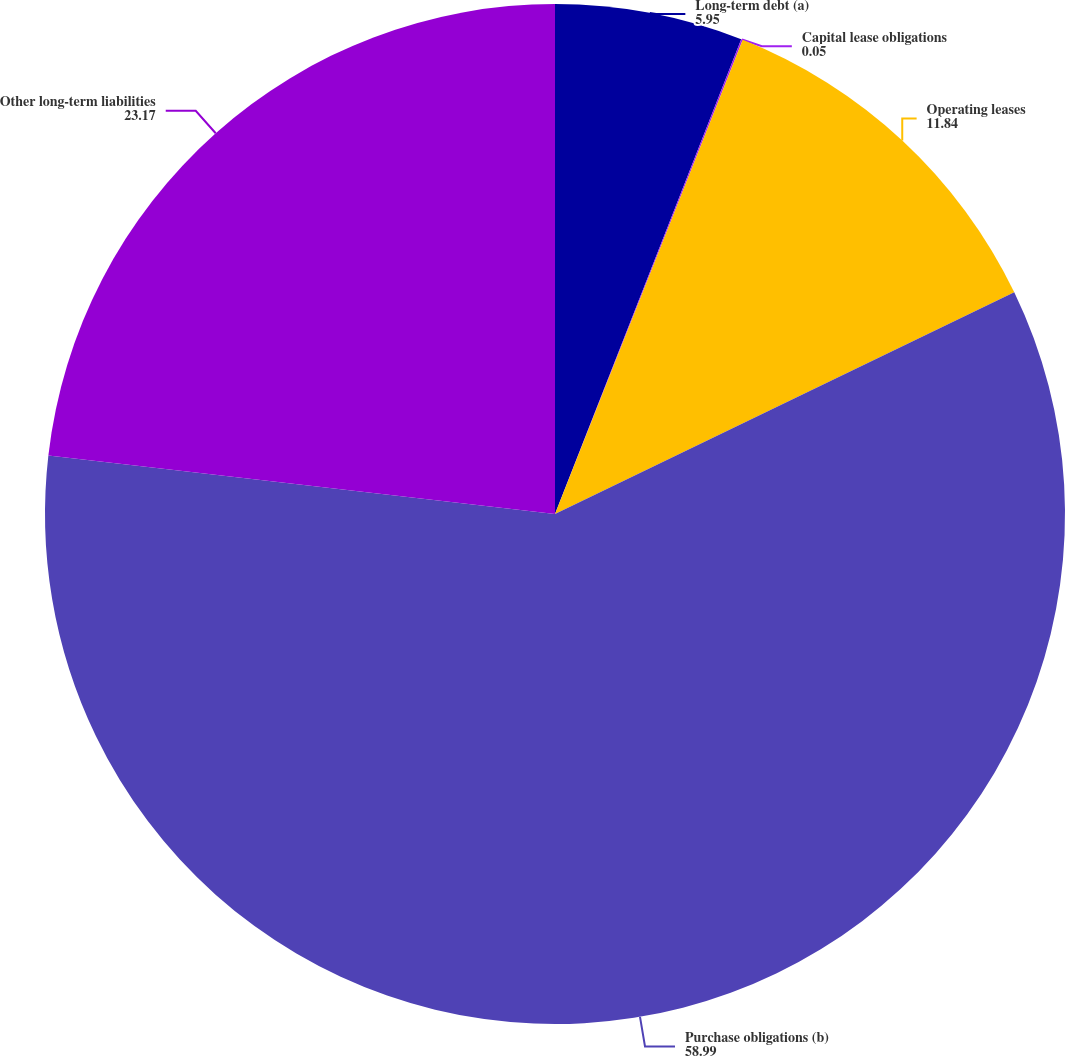<chart> <loc_0><loc_0><loc_500><loc_500><pie_chart><fcel>Long-term debt (a)<fcel>Capital lease obligations<fcel>Operating leases<fcel>Purchase obligations (b)<fcel>Other long-term liabilities<nl><fcel>5.95%<fcel>0.05%<fcel>11.84%<fcel>58.99%<fcel>23.17%<nl></chart> 